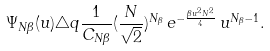Convert formula to latex. <formula><loc_0><loc_0><loc_500><loc_500>\Psi _ { N \beta } ( u ) \triangle q \frac { 1 } { C _ { N \beta } } ( \frac { N } { \sqrt { 2 } } ) ^ { N _ { \beta } } \, e ^ { - \frac { \beta u ^ { 2 } N ^ { 2 } } { 4 } } \, u ^ { N _ { \beta } - 1 } .</formula> 